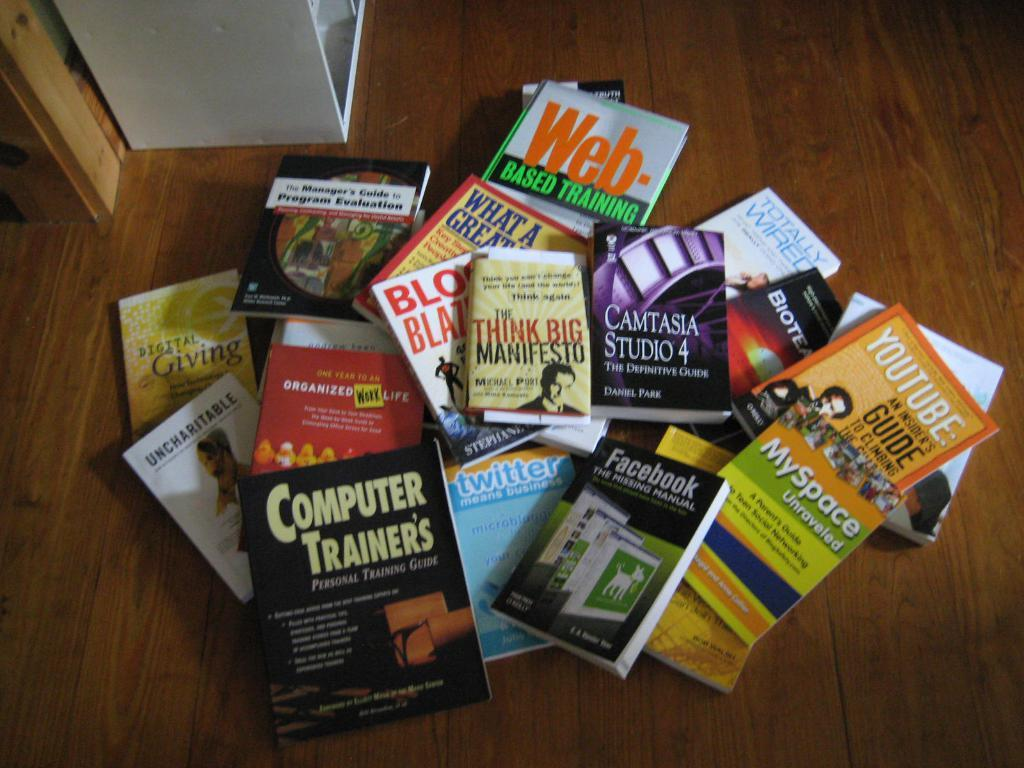Provide a one-sentence caption for the provided image. Several different books scattered on a wooden floor about technology. 